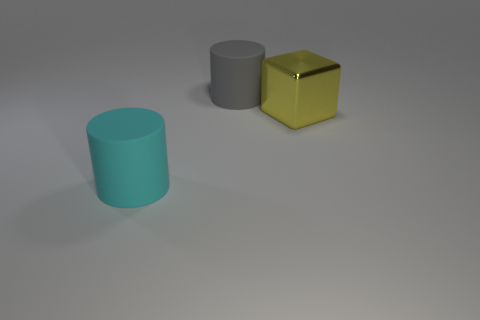What number of large yellow things have the same material as the big block?
Provide a short and direct response. 0. Are there any other gray rubber things that have the same shape as the large gray rubber thing?
Provide a short and direct response. No. What is the shape of the gray matte object that is the same size as the cube?
Your answer should be very brief. Cylinder. Do the shiny cube and the big cylinder in front of the big gray rubber object have the same color?
Provide a succinct answer. No. There is a large cylinder to the left of the gray cylinder; how many gray matte cylinders are to the left of it?
Give a very brief answer. 0. What is the size of the object that is both left of the large shiny thing and behind the cyan rubber object?
Your answer should be compact. Large. Are there any other gray matte objects of the same size as the gray object?
Your answer should be compact. No. Are there more large blocks behind the large yellow metal object than cyan rubber cylinders right of the gray rubber thing?
Offer a very short reply. No. Is the material of the big block the same as the large cylinder that is behind the cyan thing?
Your answer should be compact. No. There is a rubber object on the right side of the thing in front of the big yellow metal block; how many big metal objects are in front of it?
Your answer should be very brief. 1. 